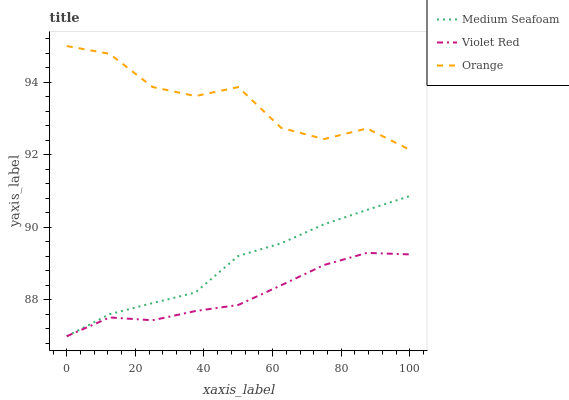Does Violet Red have the minimum area under the curve?
Answer yes or no. Yes. Does Orange have the maximum area under the curve?
Answer yes or no. Yes. Does Medium Seafoam have the minimum area under the curve?
Answer yes or no. No. Does Medium Seafoam have the maximum area under the curve?
Answer yes or no. No. Is Violet Red the smoothest?
Answer yes or no. Yes. Is Orange the roughest?
Answer yes or no. Yes. Is Medium Seafoam the smoothest?
Answer yes or no. No. Is Medium Seafoam the roughest?
Answer yes or no. No. Does Violet Red have the lowest value?
Answer yes or no. Yes. Does Orange have the highest value?
Answer yes or no. Yes. Does Medium Seafoam have the highest value?
Answer yes or no. No. Is Violet Red less than Orange?
Answer yes or no. Yes. Is Orange greater than Violet Red?
Answer yes or no. Yes. Does Violet Red intersect Medium Seafoam?
Answer yes or no. Yes. Is Violet Red less than Medium Seafoam?
Answer yes or no. No. Is Violet Red greater than Medium Seafoam?
Answer yes or no. No. Does Violet Red intersect Orange?
Answer yes or no. No. 